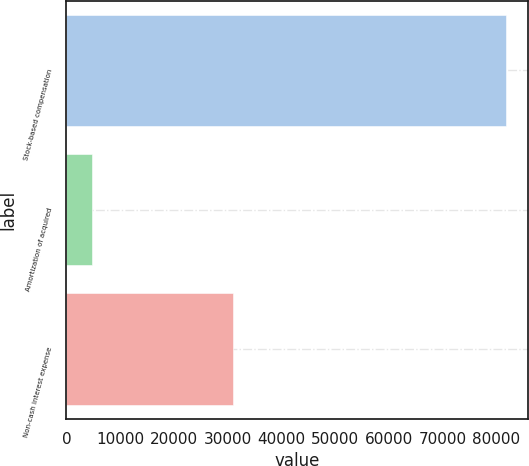Convert chart. <chart><loc_0><loc_0><loc_500><loc_500><bar_chart><fcel>Stock-based compensation<fcel>Amortization of acquired<fcel>Non-cash interest expense<nl><fcel>81887<fcel>4786<fcel>31017<nl></chart> 